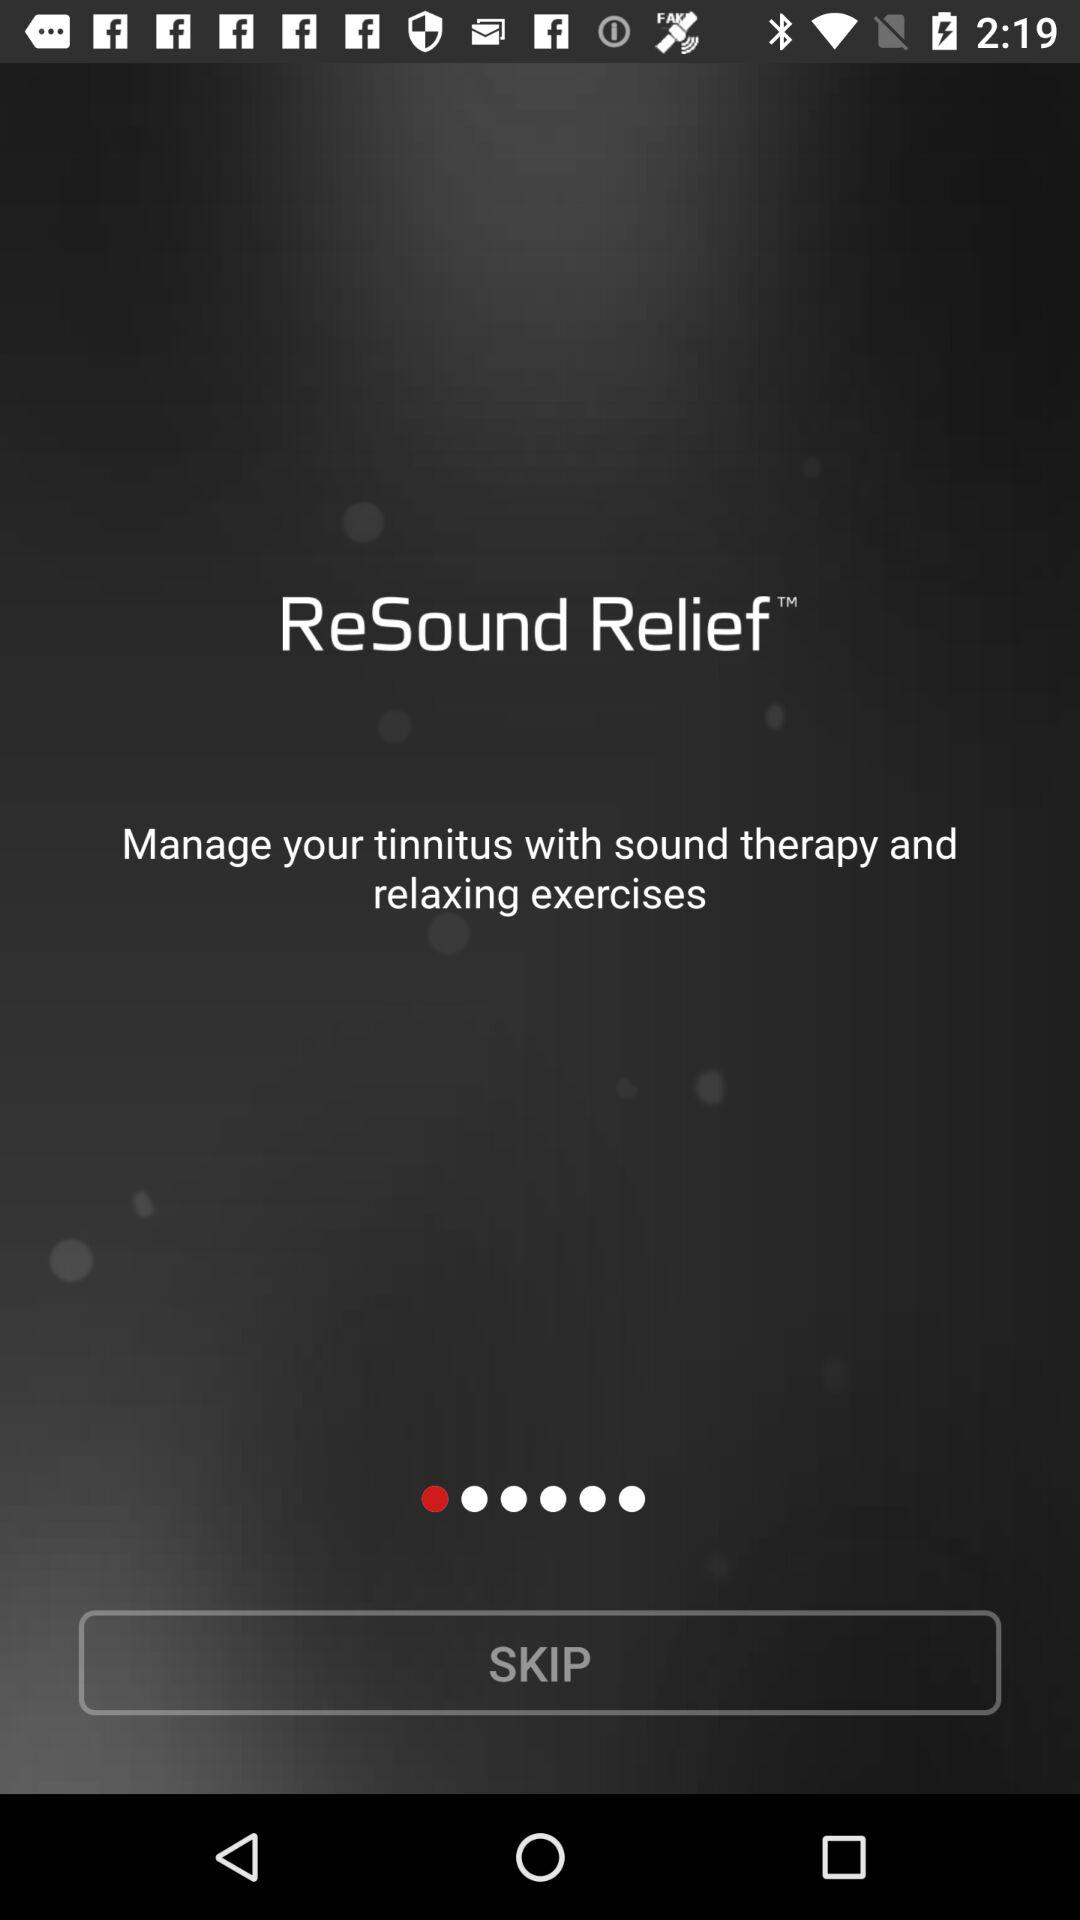How can we manage tinnitus? You can manage tinnitus with sound therapy and relaxing exercises. 